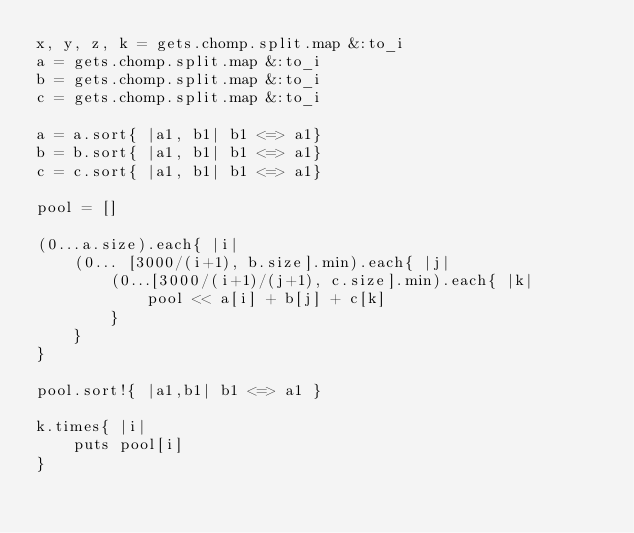<code> <loc_0><loc_0><loc_500><loc_500><_Scala_>x, y, z, k = gets.chomp.split.map &:to_i
a = gets.chomp.split.map &:to_i
b = gets.chomp.split.map &:to_i
c = gets.chomp.split.map &:to_i

a = a.sort{ |a1, b1| b1 <=> a1}
b = b.sort{ |a1, b1| b1 <=> a1}
c = c.sort{ |a1, b1| b1 <=> a1}

pool = []

(0...a.size).each{ |i|
	(0... [3000/(i+1), b.size].min).each{ |j|
		(0...[3000/(i+1)/(j+1), c.size].min).each{ |k|
			pool << a[i] + b[j] + c[k]
		}
	}
}

pool.sort!{ |a1,b1| b1 <=> a1 }

k.times{ |i|
	puts pool[i]
}
</code> 